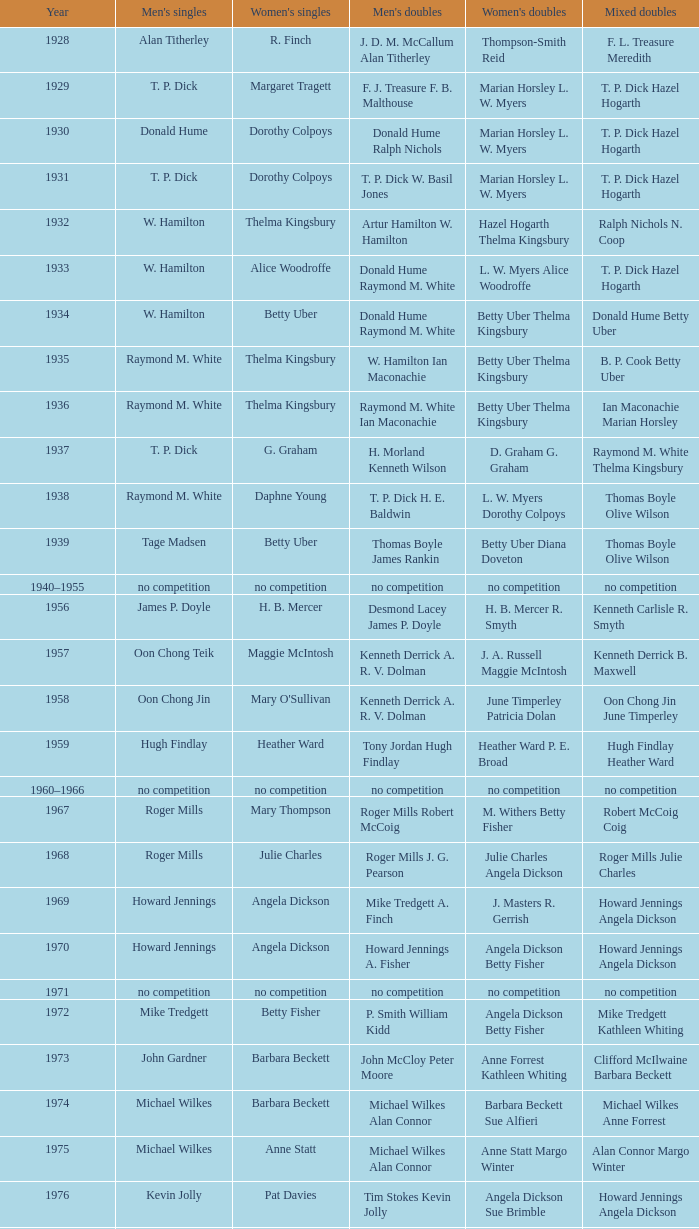Who were the champions of the women's doubles when billy gilliland and karen puttick triumphed in the mixed doubles? Jane Webster Karen Puttick. 